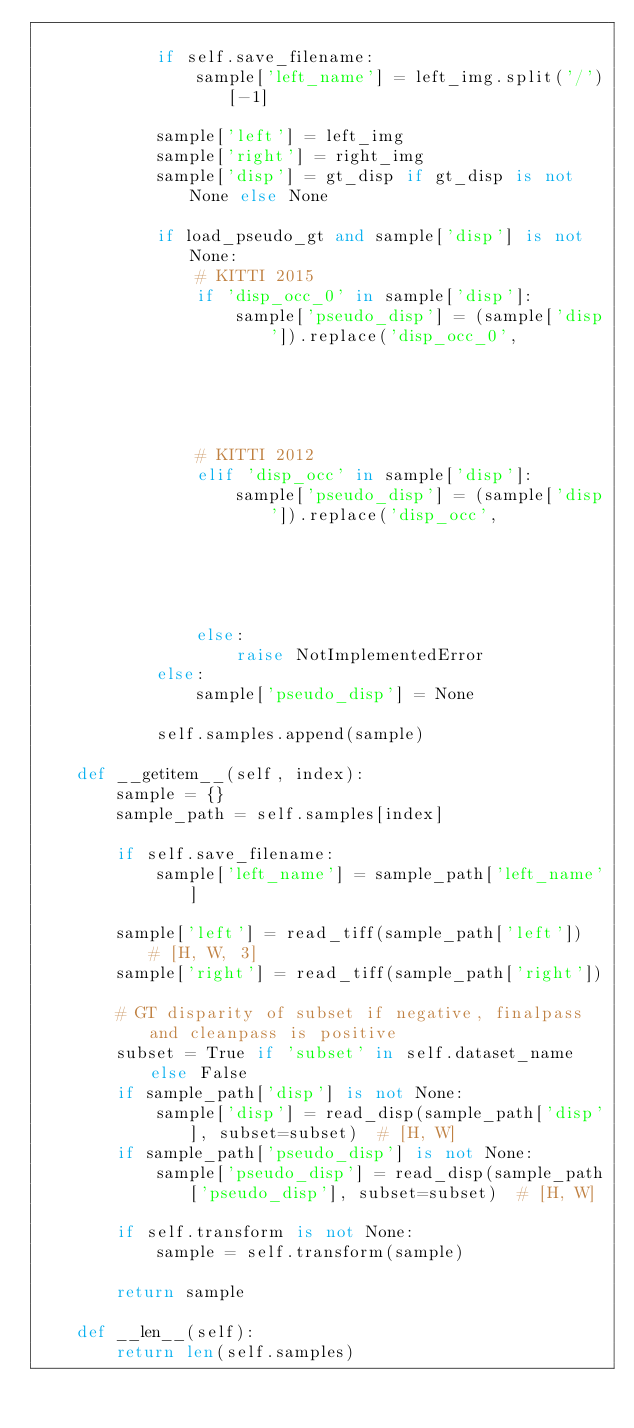Convert code to text. <code><loc_0><loc_0><loc_500><loc_500><_Python_>
            if self.save_filename:
                sample['left_name'] = left_img.split('/')[-1]

            sample['left'] = left_img
            sample['right'] = right_img
            sample['disp'] = gt_disp if gt_disp is not None else None

            if load_pseudo_gt and sample['disp'] is not None:
                # KITTI 2015
                if 'disp_occ_0' in sample['disp']:
                    sample['pseudo_disp'] = (sample['disp']).replace('disp_occ_0',
                                                                     'disp_occ_0_pseudo_gt')
                # KITTI 2012
                elif 'disp_occ' in sample['disp']:
                    sample['pseudo_disp'] = (sample['disp']).replace('disp_occ',
                                                                     'disp_occ_pseudo_gt')
                else:
                    raise NotImplementedError
            else:
                sample['pseudo_disp'] = None

            self.samples.append(sample)

    def __getitem__(self, index):
        sample = {}
        sample_path = self.samples[index]

        if self.save_filename:
            sample['left_name'] = sample_path['left_name']

        sample['left'] = read_tiff(sample_path['left'])  # [H, W, 3]
        sample['right'] = read_tiff(sample_path['right'])

        # GT disparity of subset if negative, finalpass and cleanpass is positive
        subset = True if 'subset' in self.dataset_name else False
        if sample_path['disp'] is not None:
            sample['disp'] = read_disp(sample_path['disp'], subset=subset)  # [H, W]
        if sample_path['pseudo_disp'] is not None:
            sample['pseudo_disp'] = read_disp(sample_path['pseudo_disp'], subset=subset)  # [H, W]

        if self.transform is not None:
            sample = self.transform(sample)

        return sample

    def __len__(self):
        return len(self.samples)
</code> 